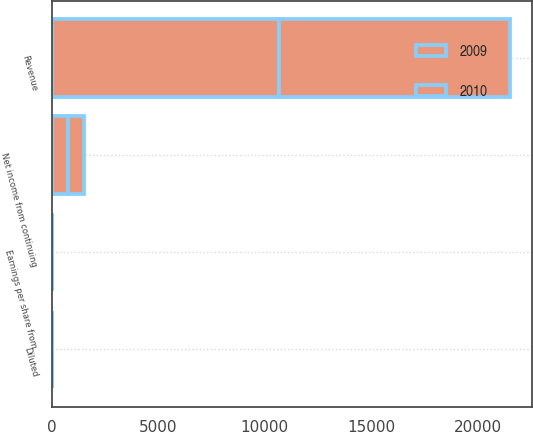Convert chart to OTSL. <chart><loc_0><loc_0><loc_500><loc_500><stacked_bar_chart><ecel><fcel>Revenue<fcel>Net income from continuing<fcel>Earnings per share from<fcel>Diluted<nl><fcel>2010<fcel>10831<fcel>736<fcel>2.17<fcel>2.14<nl><fcel>2009<fcel>10669<fcel>758<fcel>2.2<fcel>2.15<nl></chart> 